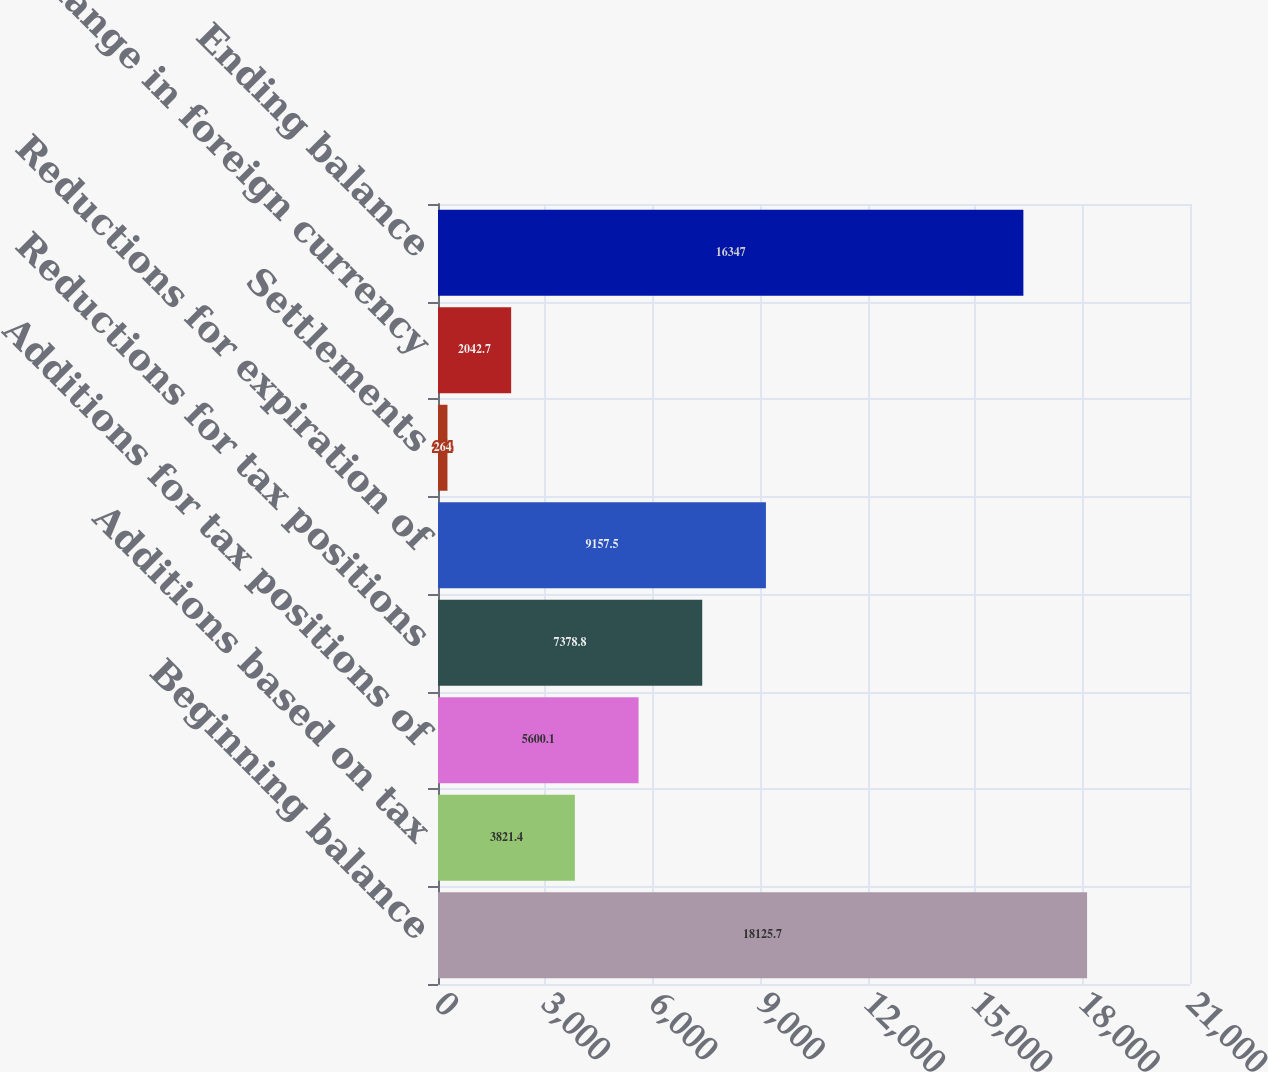Convert chart. <chart><loc_0><loc_0><loc_500><loc_500><bar_chart><fcel>Beginning balance<fcel>Additions based on tax<fcel>Additions for tax positions of<fcel>Reductions for tax positions<fcel>Reductions for expiration of<fcel>Settlements<fcel>Change in foreign currency<fcel>Ending balance<nl><fcel>18125.7<fcel>3821.4<fcel>5600.1<fcel>7378.8<fcel>9157.5<fcel>264<fcel>2042.7<fcel>16347<nl></chart> 